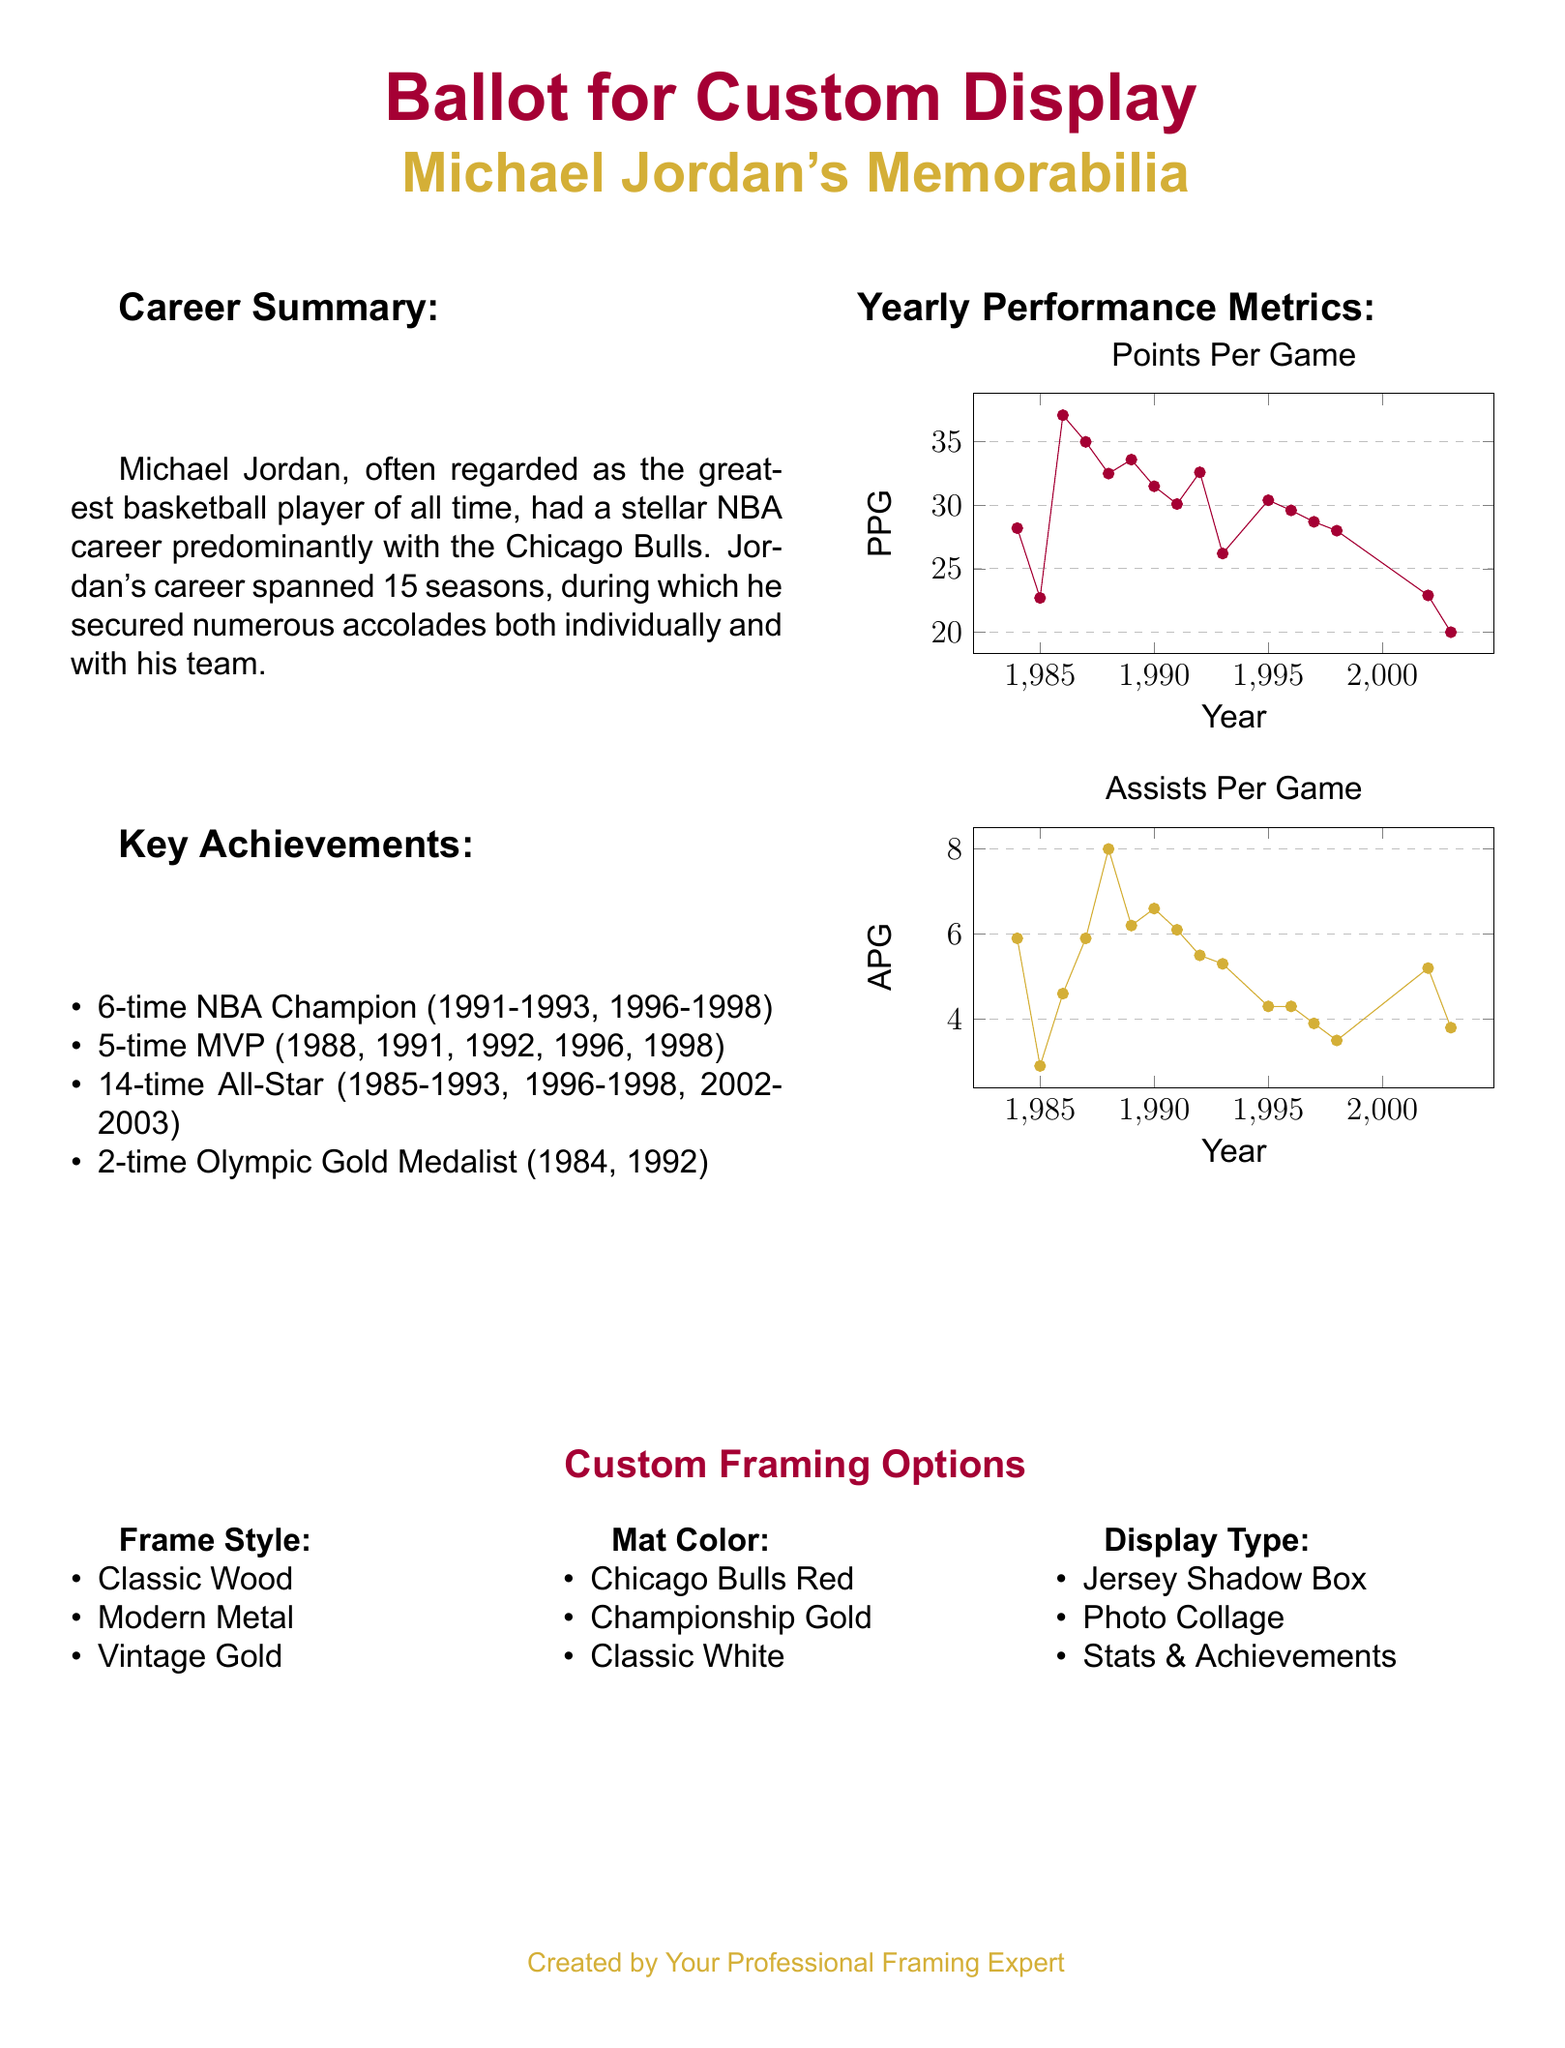What is Michael Jordan's total number of NBA Championships? The document states that Michael Jordan won 6 NBA Championships during his career.
Answer: 6 In which year did Michael Jordan achieve his first MVP award? According to the document, Michael Jordan won his first MVP award in 1988.
Answer: 1988 What color is listed as a mat option in the display preferences? The document outlines that "Championship Gold" is one of the mat color options available.
Answer: Championship Gold What is the highest Points Per Game (PPG) scored by Michael Jordan in a single season? The graph indicates that Michael Jordan scored a peak of 37.1 PPG in the year 1986.
Answer: 37.1 How many times was Michael Jordan an All-Star? Michael Jordan was selected as an All-Star 14 times during his career, as mentioned in the key achievements.
Answer: 14 Which display type is mentioned that specifically highlights statistics? The document lists "Stats & Achievements" as one of the display type options.
Answer: Stats & Achievements What was Michael Jordan's assists per game (APG) in 2002? The document presents that Michael Jordan had an assists per game (APG) of 5.2 in the year 2002.
Answer: 5.2 How many Olympic Gold Medals did Michael Jordan win? The document states that he won 2 Olympic Gold Medals during his career.
Answer: 2 Which framing style option is labeled as 'vintage'? The document indicates that "Vintage Gold" is the labeled framing style option.
Answer: Vintage Gold 